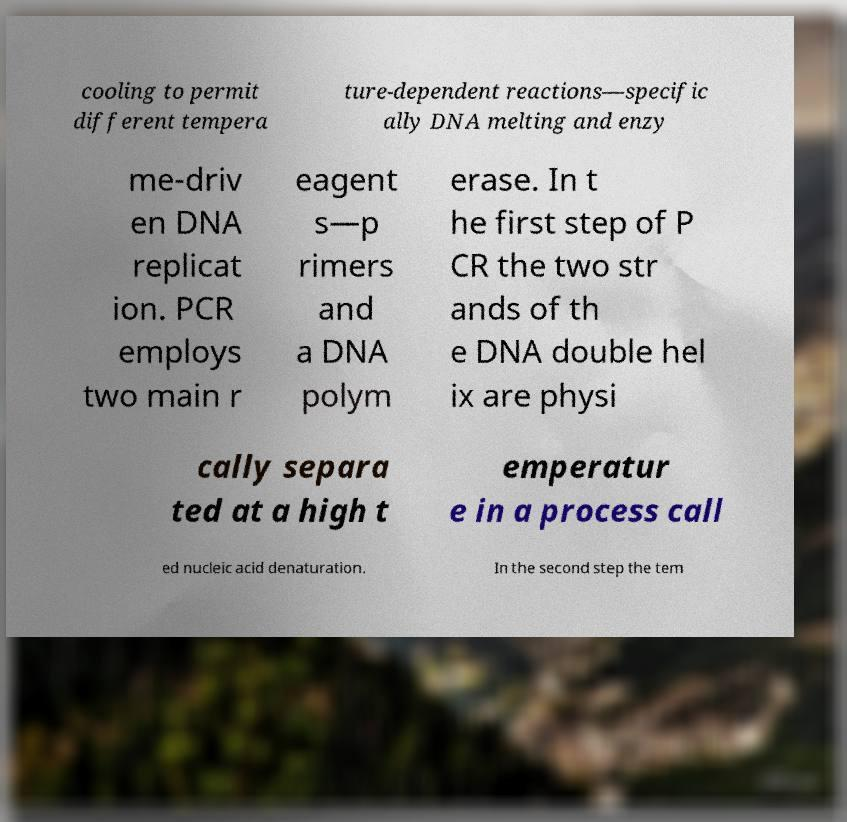There's text embedded in this image that I need extracted. Can you transcribe it verbatim? cooling to permit different tempera ture-dependent reactions—specific ally DNA melting and enzy me-driv en DNA replicat ion. PCR employs two main r eagent s—p rimers and a DNA polym erase. In t he first step of P CR the two str ands of th e DNA double hel ix are physi cally separa ted at a high t emperatur e in a process call ed nucleic acid denaturation. In the second step the tem 